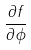Convert formula to latex. <formula><loc_0><loc_0><loc_500><loc_500>\frac { \partial f } { \partial \phi }</formula> 